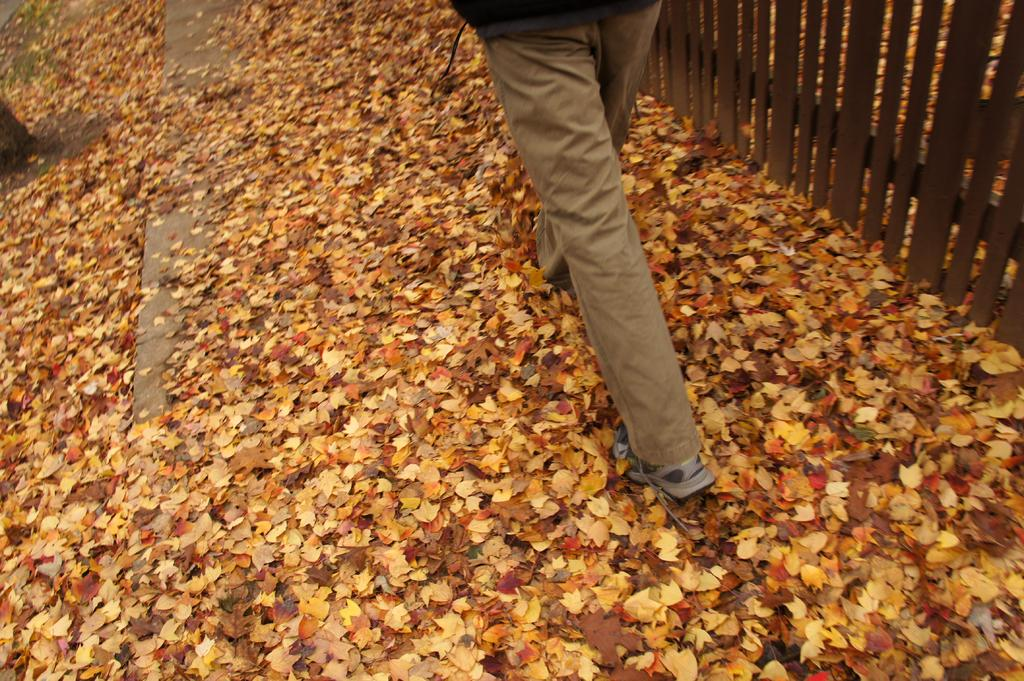What is the person in the image doing? There is a person walking in the image. What can be observed about the ground in the image? The land is covered with dry leaves. What type of fence is visible in the image? There is a wooden fence beside the person. What type of interest does the government pay to the person in the image? There is no indication in the image that the government is involved or paying any interest to the person. 